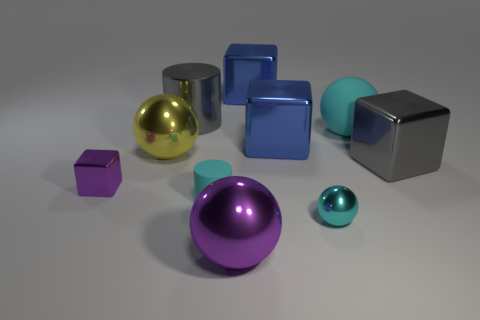Is the color of the small sphere the same as the large matte ball?
Ensure brevity in your answer.  Yes. Is there anything else of the same color as the big cylinder?
Ensure brevity in your answer.  Yes. How many objects are spheres that are behind the tiny cyan ball or blocks right of the small ball?
Keep it short and to the point. 3. What is the shape of the metal object that is both in front of the cyan cylinder and behind the purple shiny ball?
Offer a very short reply. Sphere. How many tiny purple cubes are in front of the tiny cyan thing that is on the left side of the small cyan metal ball?
Ensure brevity in your answer.  0. How many objects are big things that are on the right side of the large purple shiny ball or yellow metallic balls?
Provide a succinct answer. 5. There is a metal thing that is in front of the small cyan ball; what size is it?
Give a very brief answer. Large. What material is the big gray cylinder?
Offer a terse response. Metal. What shape is the purple metallic thing in front of the cylinder that is in front of the tiny metal block?
Provide a succinct answer. Sphere. What number of other objects are there of the same shape as the cyan shiny object?
Give a very brief answer. 3. 